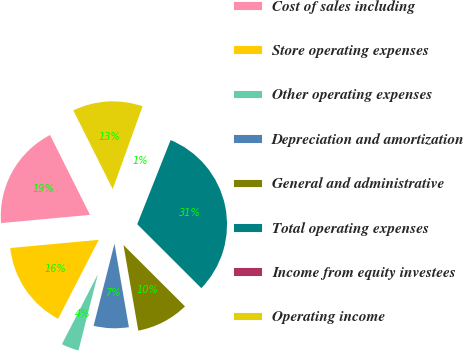<chart> <loc_0><loc_0><loc_500><loc_500><pie_chart><fcel>Cost of sales including<fcel>Store operating expenses<fcel>Other operating expenses<fcel>Depreciation and amortization<fcel>General and administrative<fcel>Total operating expenses<fcel>Income from equity investees<fcel>Operating income<nl><fcel>19.08%<fcel>15.98%<fcel>3.59%<fcel>6.69%<fcel>9.79%<fcel>31.47%<fcel>0.5%<fcel>12.89%<nl></chart> 